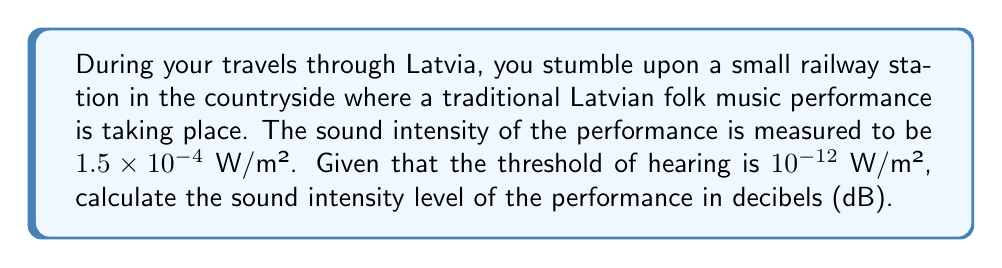Can you solve this math problem? To solve this problem, we'll use the formula for sound intensity level in decibels:

$$ \text{SIL} = 10 \log_{10}\left(\frac{I}{I_0}\right) \text{ dB} $$

Where:
- SIL is the Sound Intensity Level in decibels (dB)
- $I$ is the measured sound intensity
- $I_0$ is the threshold of hearing

Given:
- $I = 1.5 \times 10^{-4}$ W/m²
- $I_0 = 10^{-12}$ W/m²

Let's substitute these values into the formula:

$$ \text{SIL} = 10 \log_{10}\left(\frac{1.5 \times 10^{-4}}{10^{-12}}\right) \text{ dB} $$

Simplify the fraction inside the logarithm:

$$ \text{SIL} = 10 \log_{10}(1.5 \times 10^8) \text{ dB} $$

Using the properties of logarithms, we can separate this:

$$ \text{SIL} = 10 [\log_{10}(1.5) + \log_{10}(10^8)] \text{ dB} $$

$$ \text{SIL} = 10 [0.1761 + 8] \text{ dB} $$

$$ \text{SIL} = 10 (8.1761) \text{ dB} $$

$$ \text{SIL} = 81.761 \text{ dB} $$

Rounding to the nearest whole number:

$$ \text{SIL} \approx 82 \text{ dB} $$
Answer: The sound intensity level of the traditional Latvian folk music performance is approximately 82 dB. 